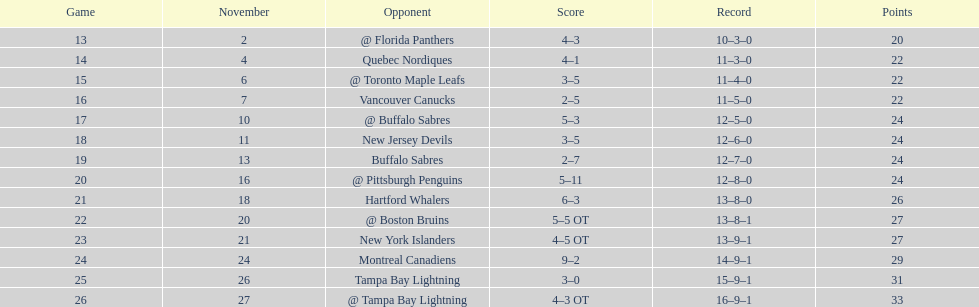Which team had a win count nearly equal to the other team? New York Islanders. 